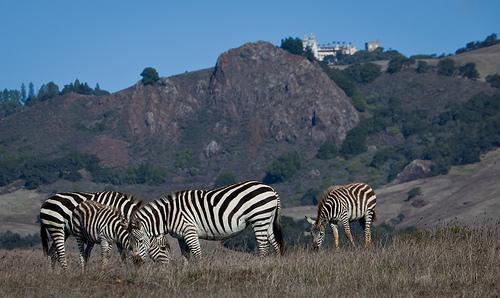How many humans are in the picture?
Give a very brief answer. 0. How many clouds are in the sky?
Give a very brief answer. 0. 